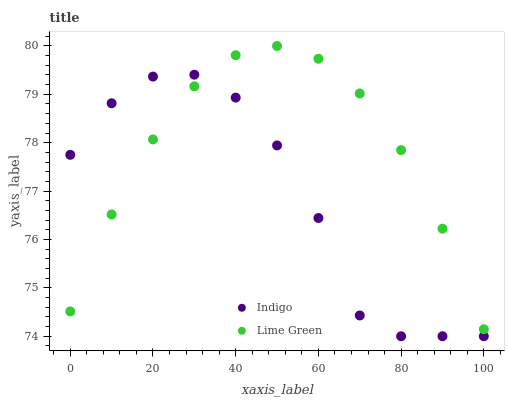Does Indigo have the minimum area under the curve?
Answer yes or no. Yes. Does Lime Green have the maximum area under the curve?
Answer yes or no. Yes. Does Indigo have the maximum area under the curve?
Answer yes or no. No. Is Lime Green the smoothest?
Answer yes or no. Yes. Is Indigo the roughest?
Answer yes or no. Yes. Is Indigo the smoothest?
Answer yes or no. No. Does Indigo have the lowest value?
Answer yes or no. Yes. Does Lime Green have the highest value?
Answer yes or no. Yes. Does Indigo have the highest value?
Answer yes or no. No. Does Indigo intersect Lime Green?
Answer yes or no. Yes. Is Indigo less than Lime Green?
Answer yes or no. No. Is Indigo greater than Lime Green?
Answer yes or no. No. 